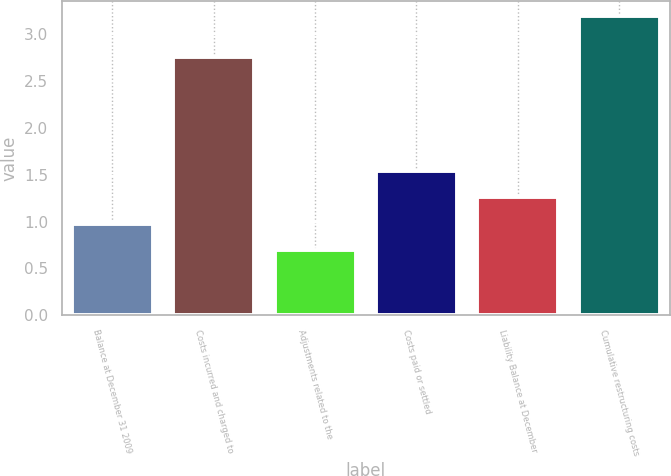<chart> <loc_0><loc_0><loc_500><loc_500><bar_chart><fcel>Balance at December 31 2009<fcel>Costs incurred and charged to<fcel>Adjustments related to the<fcel>Costs paid or settled<fcel>Liability Balance at December<fcel>Cumulative restructuring costs<nl><fcel>0.98<fcel>2.76<fcel>0.7<fcel>1.54<fcel>1.26<fcel>3.2<nl></chart> 